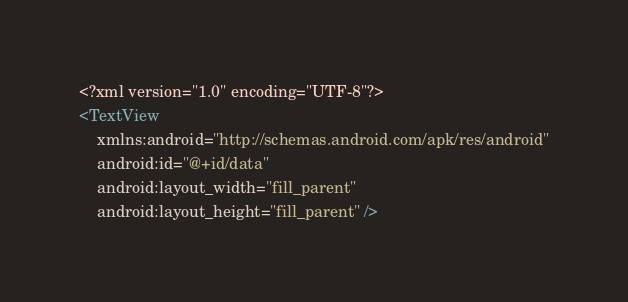Convert code to text. <code><loc_0><loc_0><loc_500><loc_500><_XML_><?xml version="1.0" encoding="UTF-8"?>
<TextView
    xmlns:android="http://schemas.android.com/apk/res/android"
    android:id="@+id/data"
    android:layout_width="fill_parent"
    android:layout_height="fill_parent" /></code> 